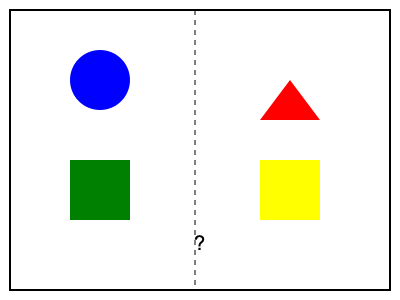As a parent advocate supporting a child with learning disabilities, you're reviewing materials on visual pattern recognition. Which shape should replace the question mark to complete the symmetrical pattern? To solve this problem, we need to analyze the pattern and identify the symmetry:

1. The image is divided into two halves by a vertical dashed line, suggesting symmetry.
2. The left side contains:
   a. A blue circle in the top-left quadrant
   b. A green square in the bottom-left quadrant
3. The right side contains:
   a. A red triangle in the top-right quadrant
   b. A yellow square in the bottom-right quadrant
   c. A question mark in the center-right area

To complete the symmetrical pattern:
4. We need to mirror the blue circle from the top-left quadrant.
5. The mirror image of a circle is still a circle.
6. The color should remain the same (blue) to maintain consistency.

Therefore, a blue circle should replace the question mark to complete the symmetrical pattern. This exercise helps develop spatial reasoning skills, which are crucial for children with learning disabilities to improve their visual processing and problem-solving abilities.
Answer: Blue circle 